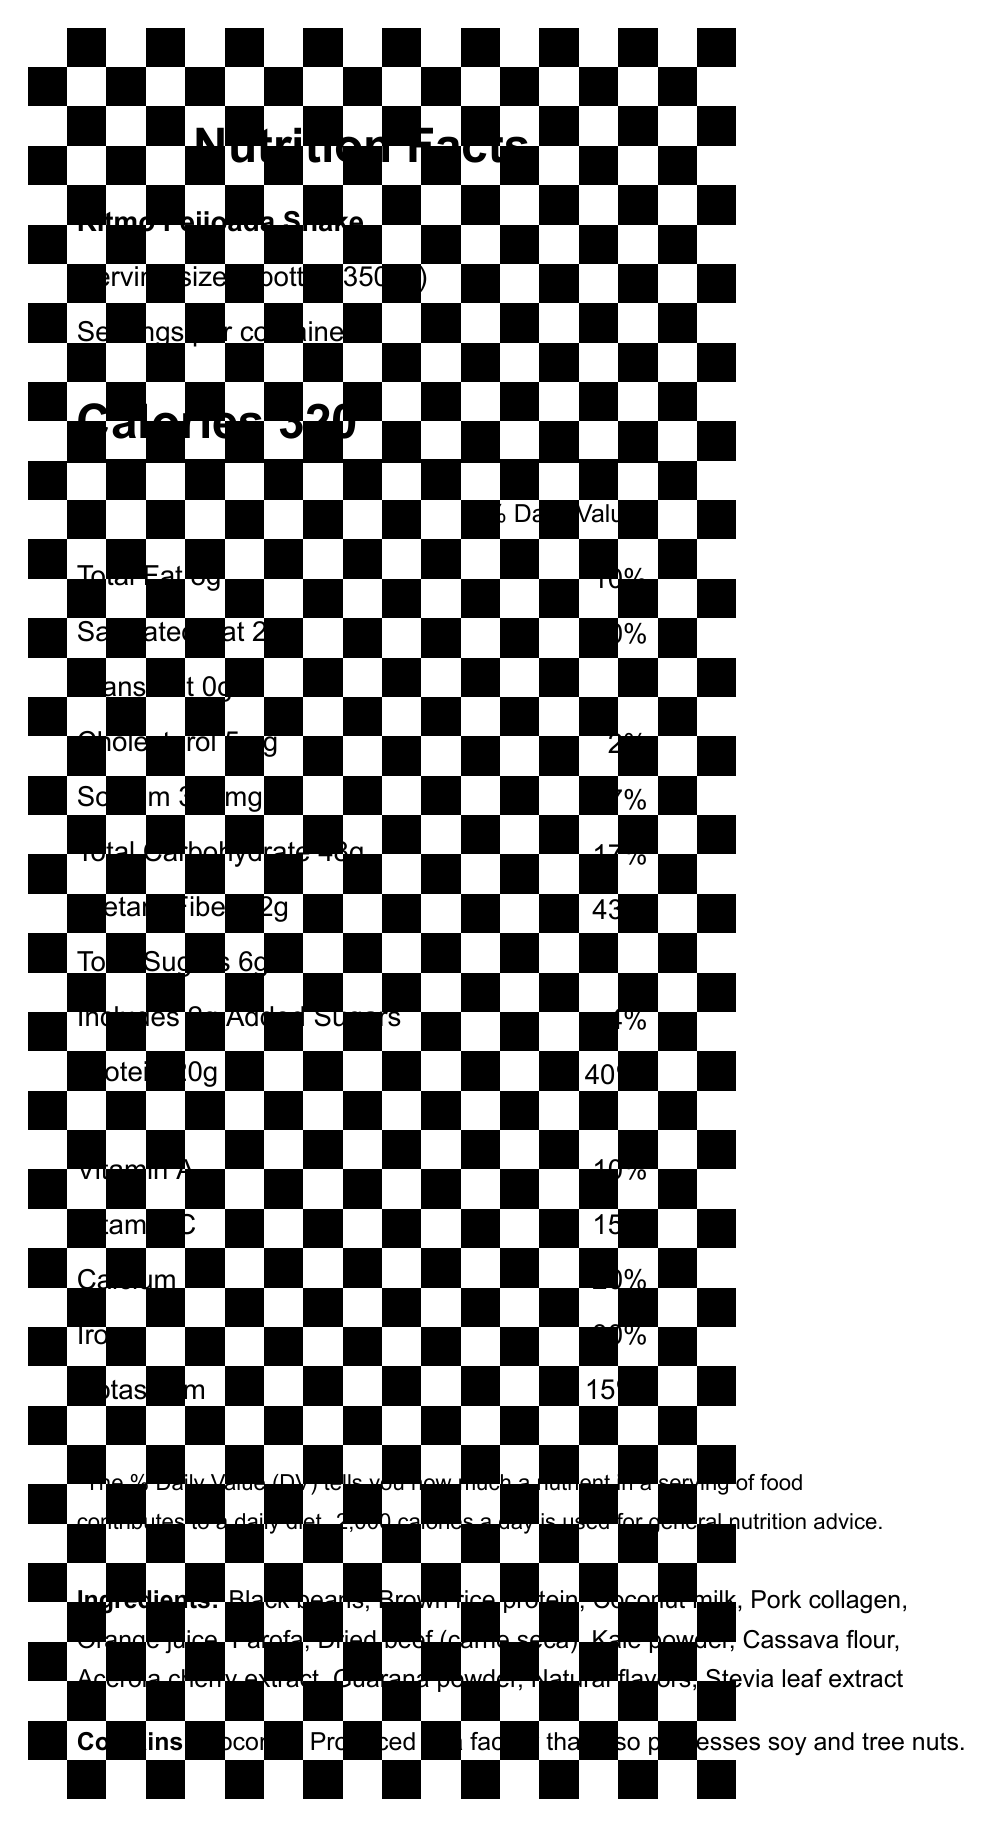what is the product name? The product name is listed at the top of the document under the title "Nutrition Facts".
Answer: Ritmo Feijoada Shake what is the serving size of the Ritmo Feijoada Shake? The serving size is mentioned below the product name: "Serving size 1 bottle (350ml)".
Answer: 1 bottle (350ml) how many calories are in a serving? The calories are listed prominently after the serving size information: "Calories 320".
Answer: 320 what are the total fat and saturated fat contents? The total fat and saturated fat contents are shown sequentially in the nutritional information section: "Total Fat 8g" and "Saturated Fat 2g".
Answer: Total Fat: 8g, Saturated Fat: 2g what is the percentage of daily value for dietary fiber? The percentage of daily value (% DV) for dietary fiber is listed next to its amount in the nutritional information: "Dietary Fiber 12g, 43%".
Answer: 43% is the shake free of trans fat? The document specifies "Trans Fat 0g" indicating that there is no trans fat in the shake.
Answer: Yes does the product contain any added sugars? The document lists "Includes 2g Added Sugars" in the nutritional information.
Answer: Yes which ingredient is not present in the Ritmo Feijoada Shake? A. Black beans B. Brown rice protein C. Peanut Butter D. Pork collagen The ingredients listed do not include peanut butter. The document mentions "Black beans", "Brown rice protein", and "Pork collagen".
Answer: C. Peanut Butter how much protein does one serving of the shake provide? A. 10g B. 15g C. 20g D. 25g The protein content is listed as "Protein 20g" in the nutritional information.
Answer: C. 20g what is the total carbohydrate content per serving? The total carbohydrate content per serving is listed as "Total Carbohydrate 48g" in the nutritional information.
Answer: 48g does the product contain any allergens? The allergen information section states, "Contains coconut. Produced in a facility that also processes soy and tree nuts."
Answer: Yes what unique feature does the packaging have related to gamification? The document mentions a gamification feature where scanning a QR code on the bottle unlocks a special character in a mobile game.
Answer: Scan QR code on bottle to unlock Samba Warrior character in 'Carnival Crush' mobile game summarize the main nutritional aspects and unique features of the Ritmo Feijoada Shake. The document provides detailed nutrition information including calories, fat, carbohydrates, proteins, vitamins, and ingredients. Additionally, it highlights allergen information, a unique gamification feature, and a sustainability note about the packaging.
Answer: The Ritmo Feijoada Shake is a meal replacement with 320 calories per serving, 8g of total fat, 48g of carbohydrates, including 12g of dietary fiber and 6g of total sugars, and 20g of protein. Its ingredients include black beans, brown rice protein, coconut milk, pork collagen, and more. It contains coconut and is processed in a facility that handles other allergens. The packaging has a QR code for unlocking a character in a mobile game and is made from recycled plastic inspired by a beach cleanup initiative. how many servings are there in each container? The document states "Servings per container 1" indicating there is only one serving in each bottle.
Answer: 1 what is not known about the product from the given document? Although the document lists the ingredients and nutritional information, it does not specify the exact flavor profile of the shake.
Answer: The exact flavor of the Ritmo Feijoada Shake 